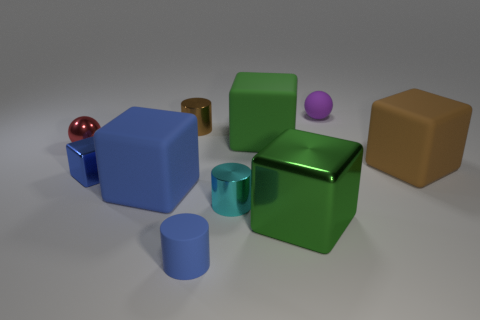The purple matte thing is what shape?
Provide a succinct answer. Sphere. What is the color of the tiny object that is the same material as the blue cylinder?
Offer a very short reply. Purple. How many small objects are either brown matte cubes or cyan metal cylinders?
Provide a succinct answer. 1. What number of cubes are behind the green metallic object?
Offer a very short reply. 4. There is a tiny shiny object that is the same shape as the big green matte object; what is its color?
Ensure brevity in your answer.  Blue. What number of matte objects are tiny blue objects or blue objects?
Give a very brief answer. 2. Are there any red things on the right side of the tiny blue thing that is right of the tiny metallic cylinder behind the green matte thing?
Your response must be concise. No. What color is the small metallic ball?
Your response must be concise. Red. There is a brown thing that is in front of the tiny shiny sphere; does it have the same shape as the big green matte thing?
Ensure brevity in your answer.  Yes. How many objects are either small cubes or small things that are to the right of the brown shiny object?
Provide a short and direct response. 4. 